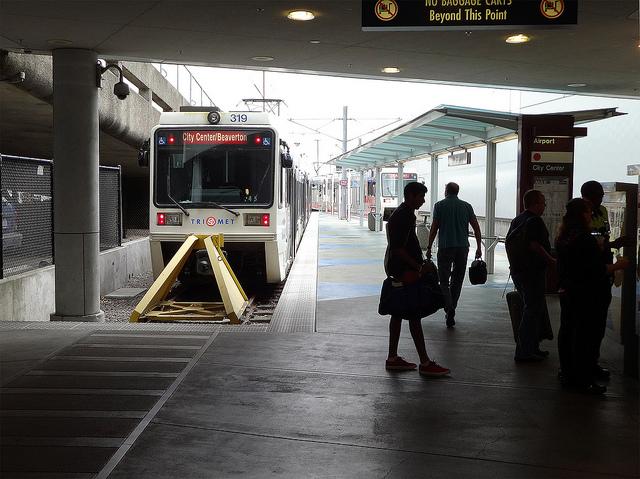What mode of travel will this man and child take?
Short answer required. Train. What color is the fence?
Concise answer only. Gray. How many people are visible in the picture?
Short answer required. 5. How many lights are on the train?
Be succinct. 4. What number is the train?
Write a very short answer. 319. 